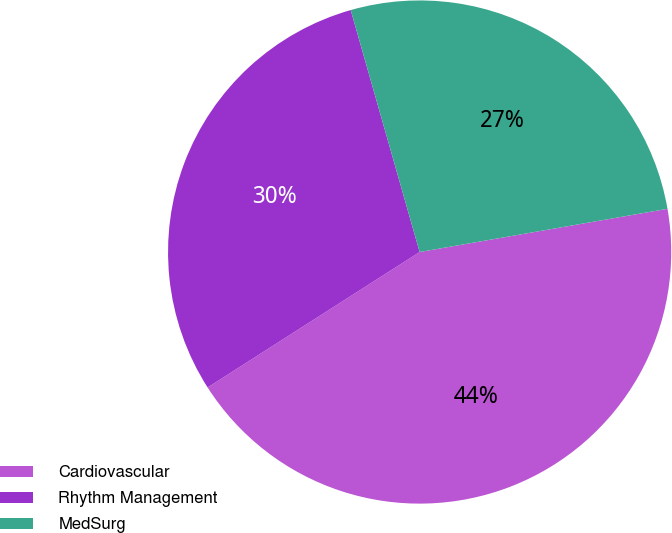Convert chart. <chart><loc_0><loc_0><loc_500><loc_500><pie_chart><fcel>Cardiovascular<fcel>Rhythm Management<fcel>MedSurg<nl><fcel>43.7%<fcel>29.63%<fcel>26.67%<nl></chart> 